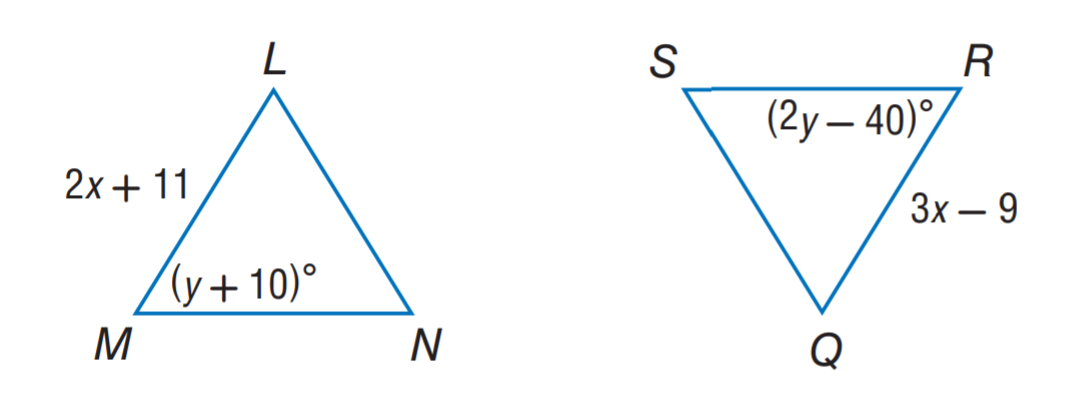Question: \triangle L M N \cong \triangle Q R S. Find y.
Choices:
A. 10
B. 20
C. 40
D. 50
Answer with the letter. Answer: D 